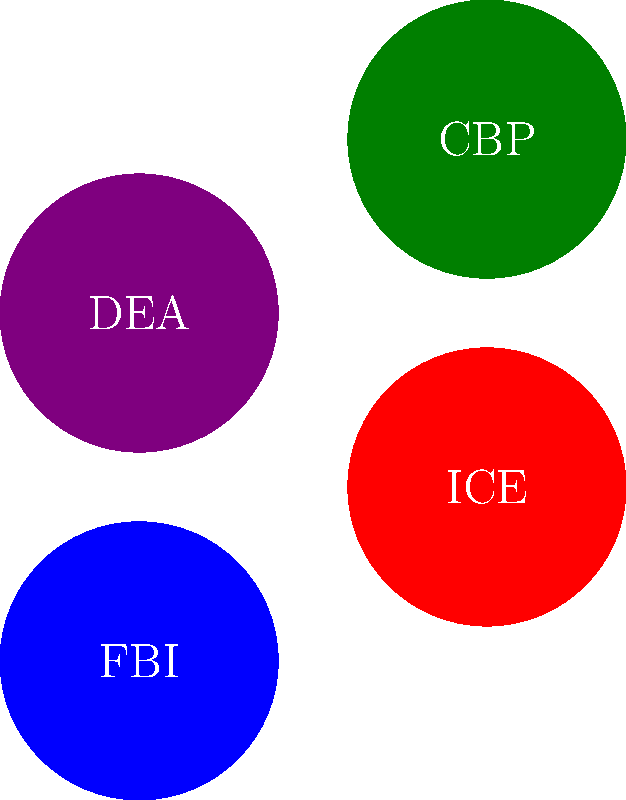Which of the law enforcement agency badges shown is most likely to be involved in investigating and prosecuting cases of human trafficking across international borders? To answer this question, we need to consider the roles of each agency represented:

1. FBI (Federal Bureau of Investigation): Primarily deals with domestic crimes and some international cases, but not specifically focused on border-related issues.

2. ICE (Immigration and Customs Enforcement): Responsible for enforcing immigration laws and investigating cross-border crimes, including human trafficking.

3. DEA (Drug Enforcement Administration): Primarily focuses on drug-related crimes and may encounter human trafficking cases, but it's not their main focus.

4. CBP (Customs and Border Protection): Primarily responsible for border security and may encounter human trafficking cases, but their main focus is on preventing illegal entry.

Given that human trafficking often involves crossing international borders, ICE is the most relevant agency for investigating and prosecuting such cases. They have specialized units dedicated to combating human trafficking and work closely with international partners to address this issue.
Answer: ICE (Immigration and Customs Enforcement) 